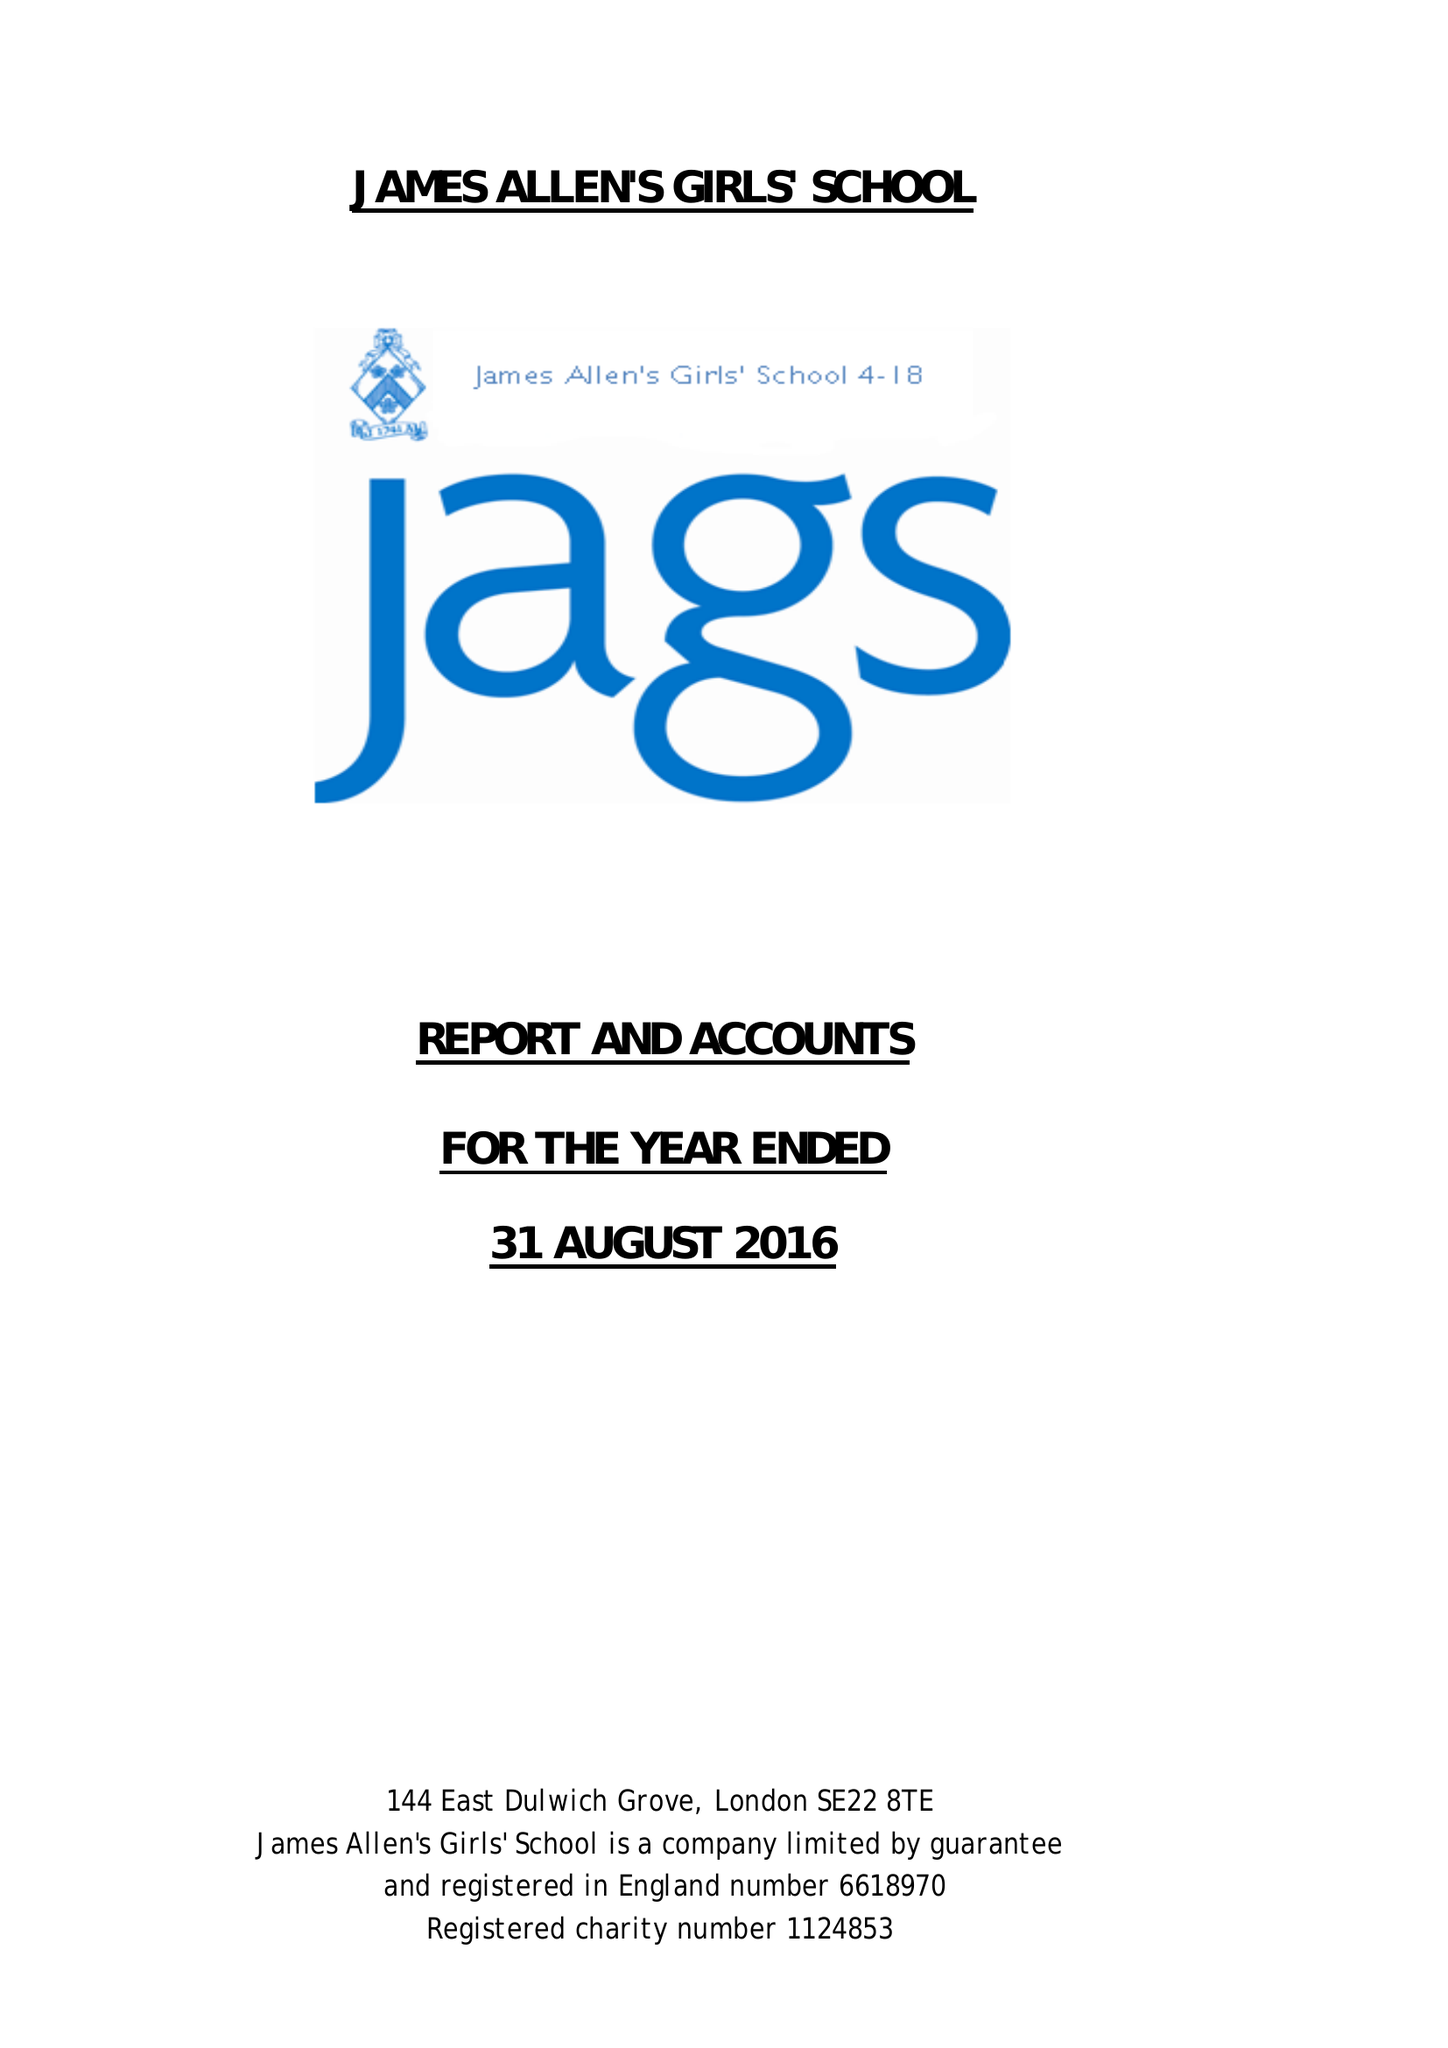What is the value for the address__street_line?
Answer the question using a single word or phrase. 144 EAST DULWICH GROVE 